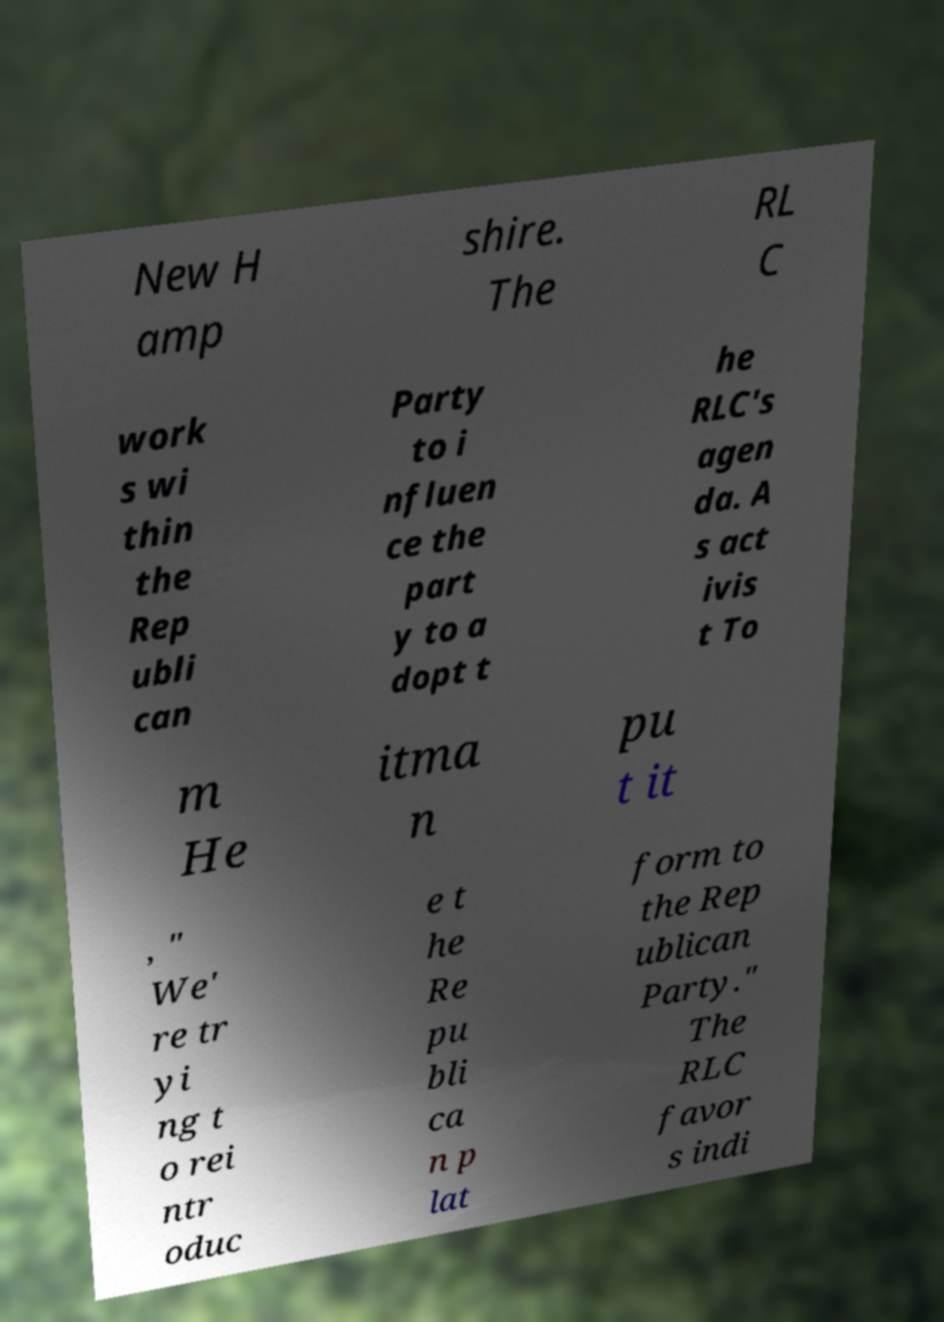Could you extract and type out the text from this image? New H amp shire. The RL C work s wi thin the Rep ubli can Party to i nfluen ce the part y to a dopt t he RLC's agen da. A s act ivis t To m He itma n pu t it , " We' re tr yi ng t o rei ntr oduc e t he Re pu bli ca n p lat form to the Rep ublican Party." The RLC favor s indi 